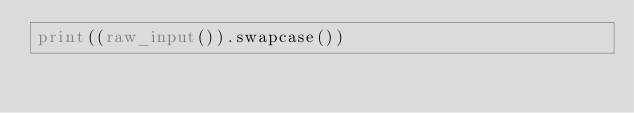<code> <loc_0><loc_0><loc_500><loc_500><_Python_>print((raw_input()).swapcase())</code> 